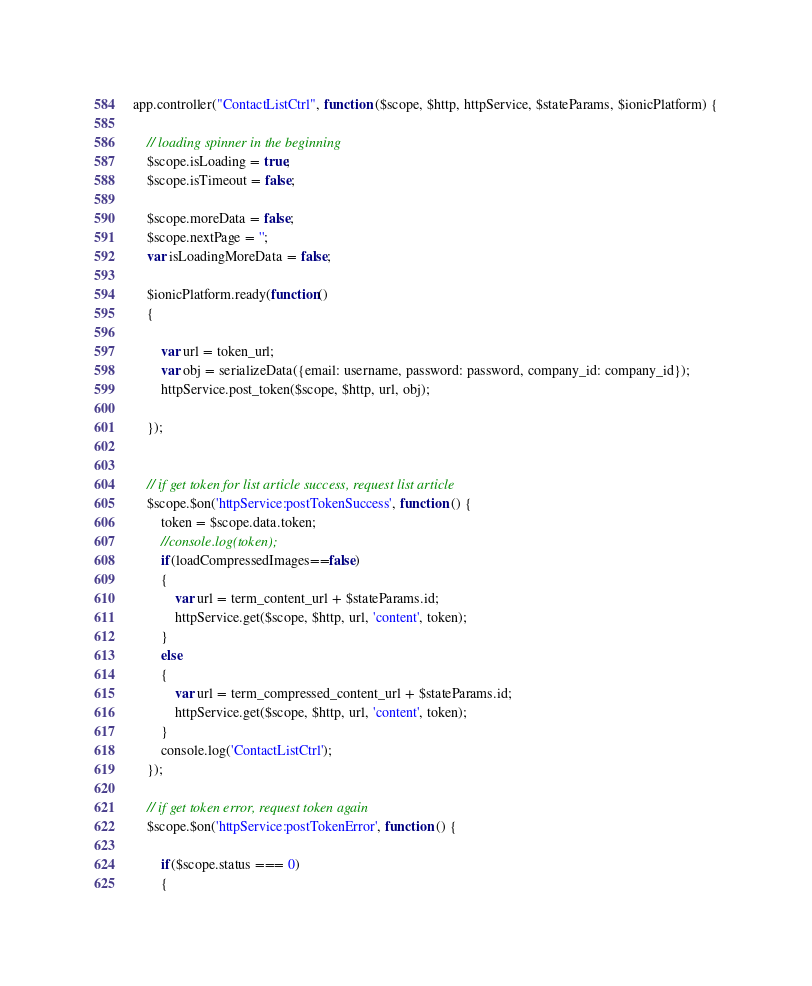Convert code to text. <code><loc_0><loc_0><loc_500><loc_500><_JavaScript_>app.controller("ContactListCtrl", function ($scope, $http, httpService, $stateParams, $ionicPlatform) {

    // loading spinner in the beginning
    $scope.isLoading = true;
    $scope.isTimeout = false;

    $scope.moreData = false;
    $scope.nextPage = '';
    var isLoadingMoreData = false;

    $ionicPlatform.ready(function()
    {

        var url = token_url;
        var obj = serializeData({email: username, password: password, company_id: company_id});
        httpService.post_token($scope, $http, url, obj);

    });


    // if get token for list article success, request list article
    $scope.$on('httpService:postTokenSuccess', function () {
        token = $scope.data.token;
        //console.log(token);
        if(loadCompressedImages==false)
        {
            var url = term_content_url + $stateParams.id;
            httpService.get($scope, $http, url, 'content', token);
        }
        else
        {
            var url = term_compressed_content_url + $stateParams.id;
            httpService.get($scope, $http, url, 'content', token);
        }
        console.log('ContactListCtrl');
    });

    // if get token error, request token again
    $scope.$on('httpService:postTokenError', function () {

        if($scope.status === 0)
        {</code> 